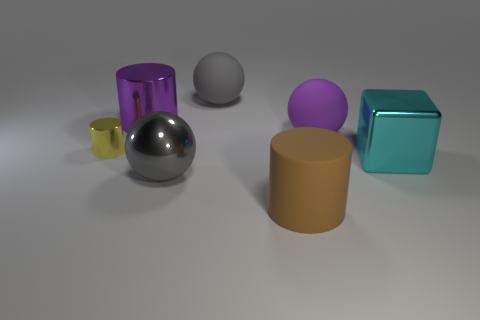Can you describe the lighting and shadows in the image? The lighting in the image is soft and diffused, coming from above. This is indicated by the gentle shadows cast by each object onto the light gray surface. The shadows are relatively short, suggesting that the light source is not positioned at a low angle. The softness of the shadows indicates that the light source might be large or that there is some form of diffusion happening. 